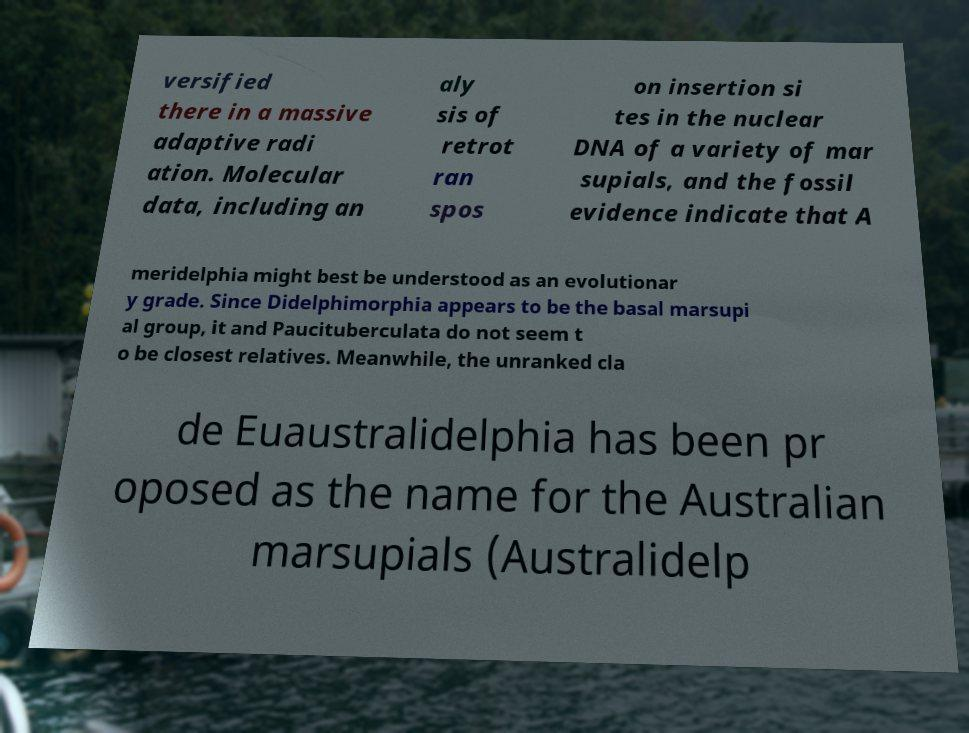Could you assist in decoding the text presented in this image and type it out clearly? versified there in a massive adaptive radi ation. Molecular data, including an aly sis of retrot ran spos on insertion si tes in the nuclear DNA of a variety of mar supials, and the fossil evidence indicate that A meridelphia might best be understood as an evolutionar y grade. Since Didelphimorphia appears to be the basal marsupi al group, it and Paucituberculata do not seem t o be closest relatives. Meanwhile, the unranked cla de Euaustralidelphia has been pr oposed as the name for the Australian marsupials (Australidelp 